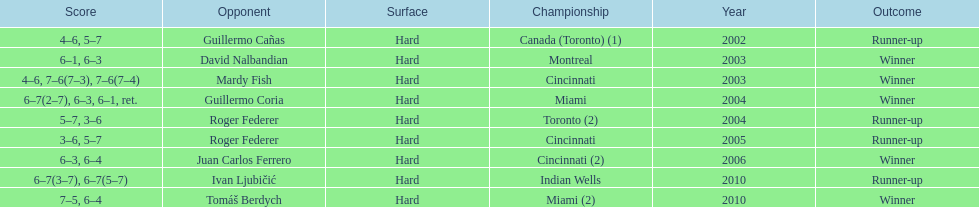How many continuous years was there a hard surface at the championship? 9. 